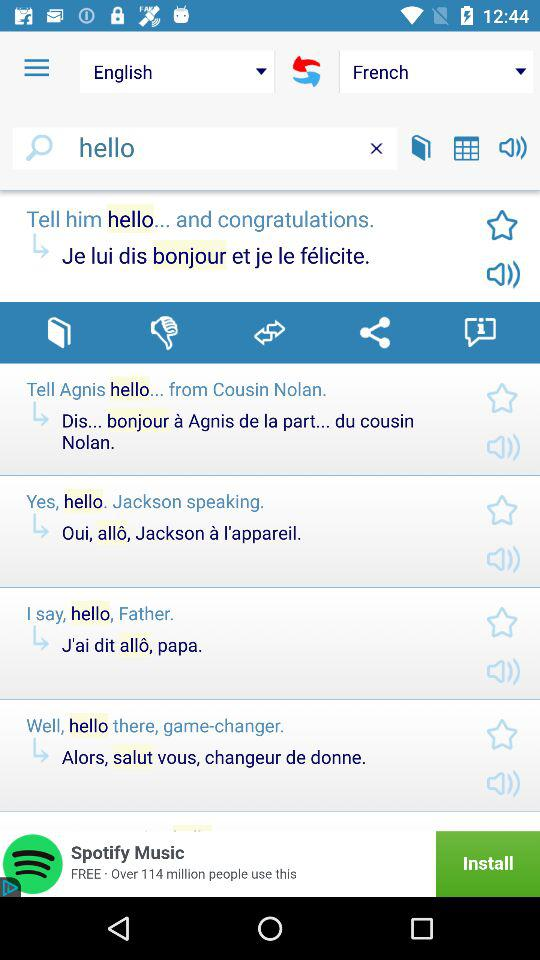How many languages are available on this app?
Answer the question using a single word or phrase. 2 